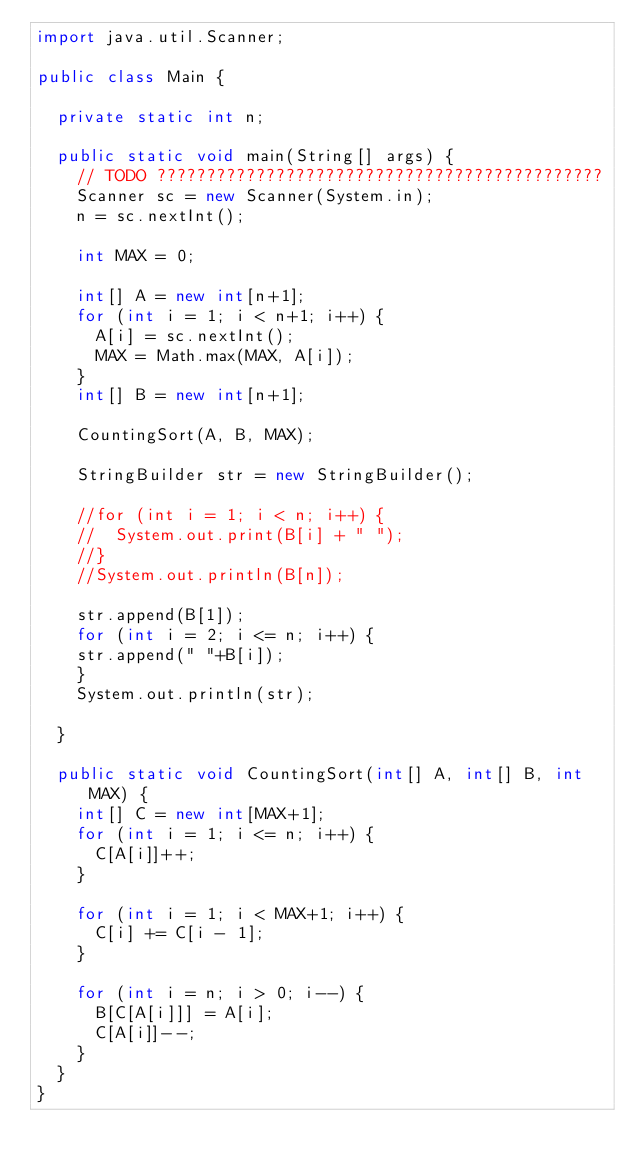<code> <loc_0><loc_0><loc_500><loc_500><_Java_>import java.util.Scanner;

public class Main {

	private static int n;

	public static void main(String[] args) {
		// TODO ?????????????????????????????????????????????
		Scanner sc = new Scanner(System.in);
		n = sc.nextInt();

		int MAX = 0;

		int[] A = new int[n+1];
		for (int i = 1; i < n+1; i++) {
			A[i] = sc.nextInt();
			MAX = Math.max(MAX, A[i]);
		}
		int[] B = new int[n+1];

		CountingSort(A, B, MAX);
		
		StringBuilder str = new StringBuilder();

		//for (int i = 1; i < n; i++) {
		//	System.out.print(B[i] + " ");
		//}
		//System.out.println(B[n]);
		
		str.append(B[1]);
		for (int i = 2; i <= n; i++) {
		str.append(" "+B[i]);
		}
		System.out.println(str);

	}

	public static void CountingSort(int[] A, int[] B, int MAX) {
		int[] C = new int[MAX+1];
		for (int i = 1; i <= n; i++) {
			C[A[i]]++;
		}

		for (int i = 1; i < MAX+1; i++) {
			C[i] += C[i - 1];
		}

		for (int i = n; i > 0; i--) {
			B[C[A[i]]] = A[i];
			C[A[i]]--;
		}
	}
}</code> 